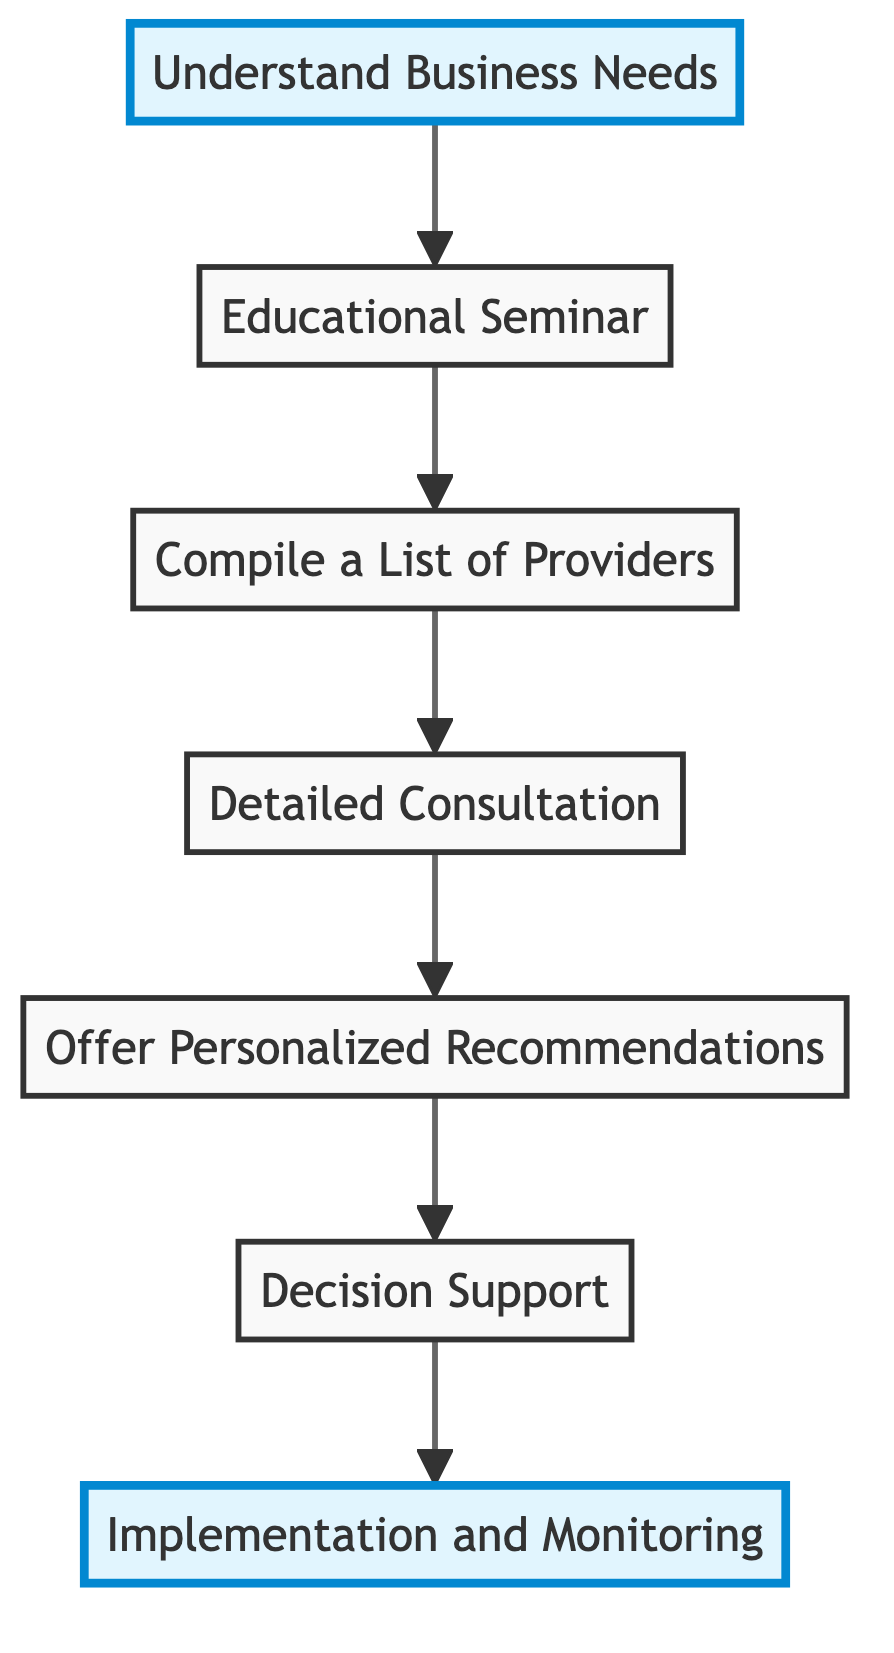What is the first step in connecting business owners with insurance providers? The diagram presents a sequence starting from the bottom to the top. The first step in the flow chart is "Understand Business Needs."
Answer: Understand Business Needs How many total steps are there in this flow chart? The diagram lists a total of seven steps, starting from "Understand Business Needs" and going up to "Implementation and Monitoring."
Answer: 7 What is the last step in the insurance connection process? The final step indicated at the top of the flow chart is "Implementation and Monitoring."
Answer: Implementation and Monitoring Which step involves educating business owners about insurance policies? In the sequence, the step that focuses on education is "Educational Seminar," which follows directly after "Understand Business Needs."
Answer: Educational Seminar What is the relationship between "Compile a List of Providers" and "Detailed Consultation"? "Compile a List of Providers" leads directly to "Detailed Consultation," indicating that once the list is compiled, consultations can be arranged.
Answer: Leads to What are the specific outcomes of the "Decision Support" step? The "Decision Support" step assists business owners in comparing offers and making an informed decision, which is a critical part of the selection process.
Answer: Comparing offers What step offers personalized insurance recommendations? The step that provides tailored insurance options is labeled "Offer Personalized Recommendations," which comes right after detailed consultations.
Answer: Offer Personalized Recommendations 